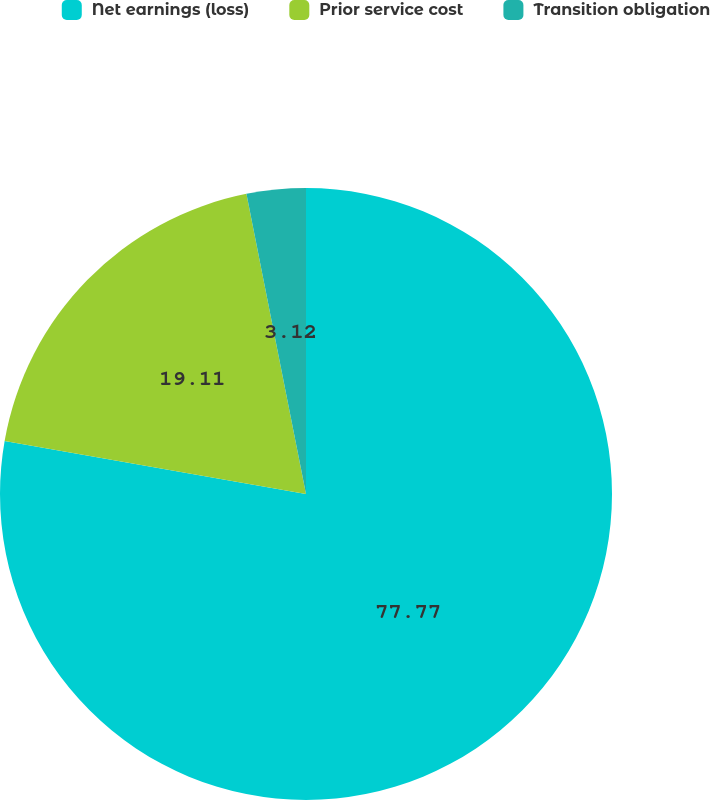Convert chart to OTSL. <chart><loc_0><loc_0><loc_500><loc_500><pie_chart><fcel>Net earnings (loss)<fcel>Prior service cost<fcel>Transition obligation<nl><fcel>77.78%<fcel>19.11%<fcel>3.12%<nl></chart> 